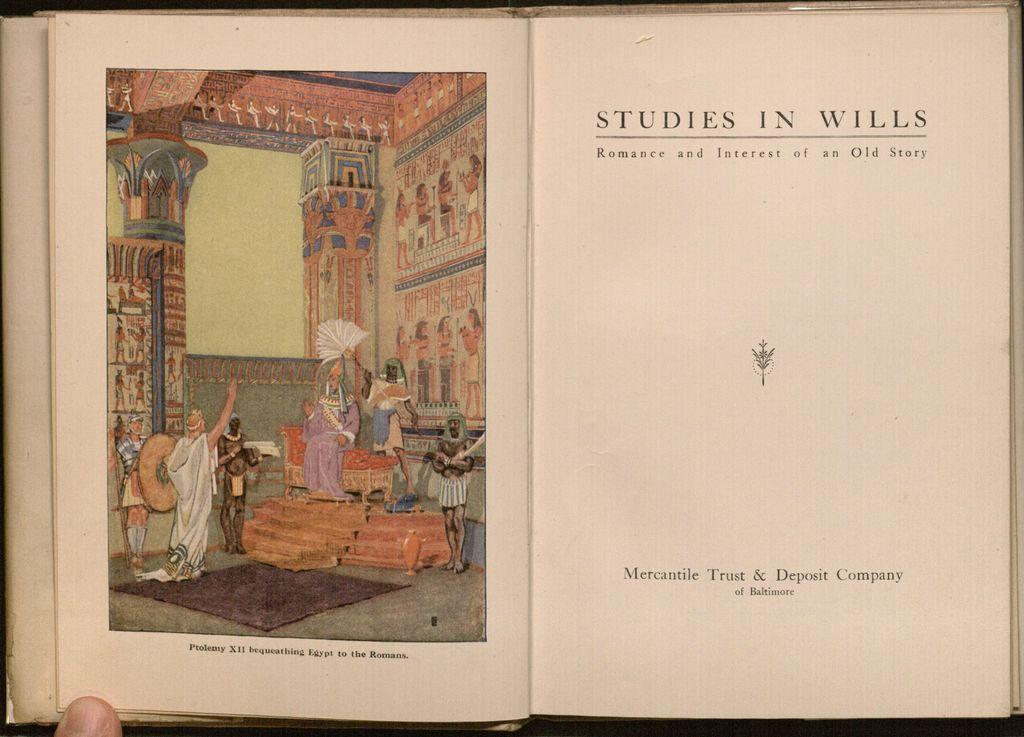<image>
Write a terse but informative summary of the picture. Studies in wills romance and interest of an Old story chapter book. 